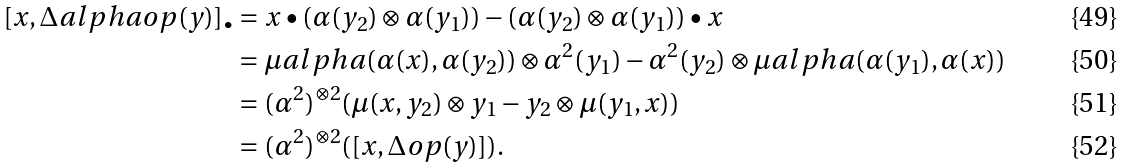Convert formula to latex. <formula><loc_0><loc_0><loc_500><loc_500>[ x , \Delta a l p h a o p ( y ) ] _ { \bullet } & = x \bullet ( \alpha ( y _ { 2 } ) \otimes \alpha ( y _ { 1 } ) ) - ( \alpha ( y _ { 2 } ) \otimes \alpha ( y _ { 1 } ) ) \bullet x \\ & = \mu a l p h a ( \alpha ( x ) , \alpha ( y _ { 2 } ) ) \otimes \alpha ^ { 2 } ( y _ { 1 } ) - \alpha ^ { 2 } ( y _ { 2 } ) \otimes \mu a l p h a ( \alpha ( y _ { 1 } ) , \alpha ( x ) ) \\ & = ( \alpha ^ { 2 } ) ^ { \otimes 2 } ( \mu ( x , y _ { 2 } ) \otimes y _ { 1 } - y _ { 2 } \otimes \mu ( y _ { 1 } , x ) ) \\ & = ( \alpha ^ { 2 } ) ^ { \otimes 2 } ( [ x , \Delta o p ( y ) ] ) .</formula> 